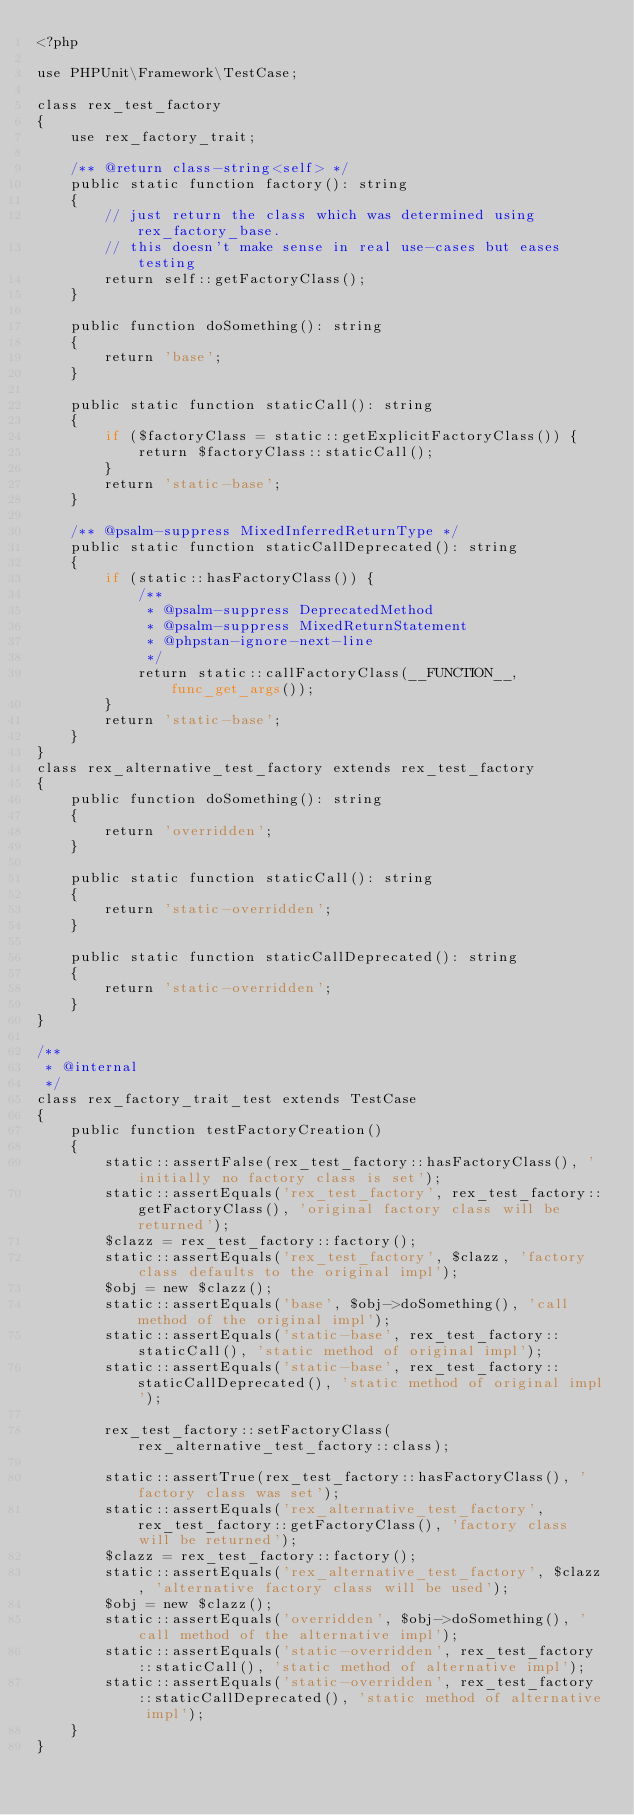<code> <loc_0><loc_0><loc_500><loc_500><_PHP_><?php

use PHPUnit\Framework\TestCase;

class rex_test_factory
{
    use rex_factory_trait;

    /** @return class-string<self> */
    public static function factory(): string
    {
        // just return the class which was determined using rex_factory_base.
        // this doesn't make sense in real use-cases but eases testing
        return self::getFactoryClass();
    }

    public function doSomething(): string
    {
        return 'base';
    }

    public static function staticCall(): string
    {
        if ($factoryClass = static::getExplicitFactoryClass()) {
            return $factoryClass::staticCall();
        }
        return 'static-base';
    }

    /** @psalm-suppress MixedInferredReturnType */
    public static function staticCallDeprecated(): string
    {
        if (static::hasFactoryClass()) {
            /**
             * @psalm-suppress DeprecatedMethod
             * @psalm-suppress MixedReturnStatement
             * @phpstan-ignore-next-line
             */
            return static::callFactoryClass(__FUNCTION__, func_get_args());
        }
        return 'static-base';
    }
}
class rex_alternative_test_factory extends rex_test_factory
{
    public function doSomething(): string
    {
        return 'overridden';
    }

    public static function staticCall(): string
    {
        return 'static-overridden';
    }

    public static function staticCallDeprecated(): string
    {
        return 'static-overridden';
    }
}

/**
 * @internal
 */
class rex_factory_trait_test extends TestCase
{
    public function testFactoryCreation()
    {
        static::assertFalse(rex_test_factory::hasFactoryClass(), 'initially no factory class is set');
        static::assertEquals('rex_test_factory', rex_test_factory::getFactoryClass(), 'original factory class will be returned');
        $clazz = rex_test_factory::factory();
        static::assertEquals('rex_test_factory', $clazz, 'factory class defaults to the original impl');
        $obj = new $clazz();
        static::assertEquals('base', $obj->doSomething(), 'call method of the original impl');
        static::assertEquals('static-base', rex_test_factory::staticCall(), 'static method of original impl');
        static::assertEquals('static-base', rex_test_factory::staticCallDeprecated(), 'static method of original impl');

        rex_test_factory::setFactoryClass(rex_alternative_test_factory::class);

        static::assertTrue(rex_test_factory::hasFactoryClass(), 'factory class was set');
        static::assertEquals('rex_alternative_test_factory', rex_test_factory::getFactoryClass(), 'factory class will be returned');
        $clazz = rex_test_factory::factory();
        static::assertEquals('rex_alternative_test_factory', $clazz, 'alternative factory class will be used');
        $obj = new $clazz();
        static::assertEquals('overridden', $obj->doSomething(), 'call method of the alternative impl');
        static::assertEquals('static-overridden', rex_test_factory::staticCall(), 'static method of alternative impl');
        static::assertEquals('static-overridden', rex_test_factory::staticCallDeprecated(), 'static method of alternative impl');
    }
}
</code> 